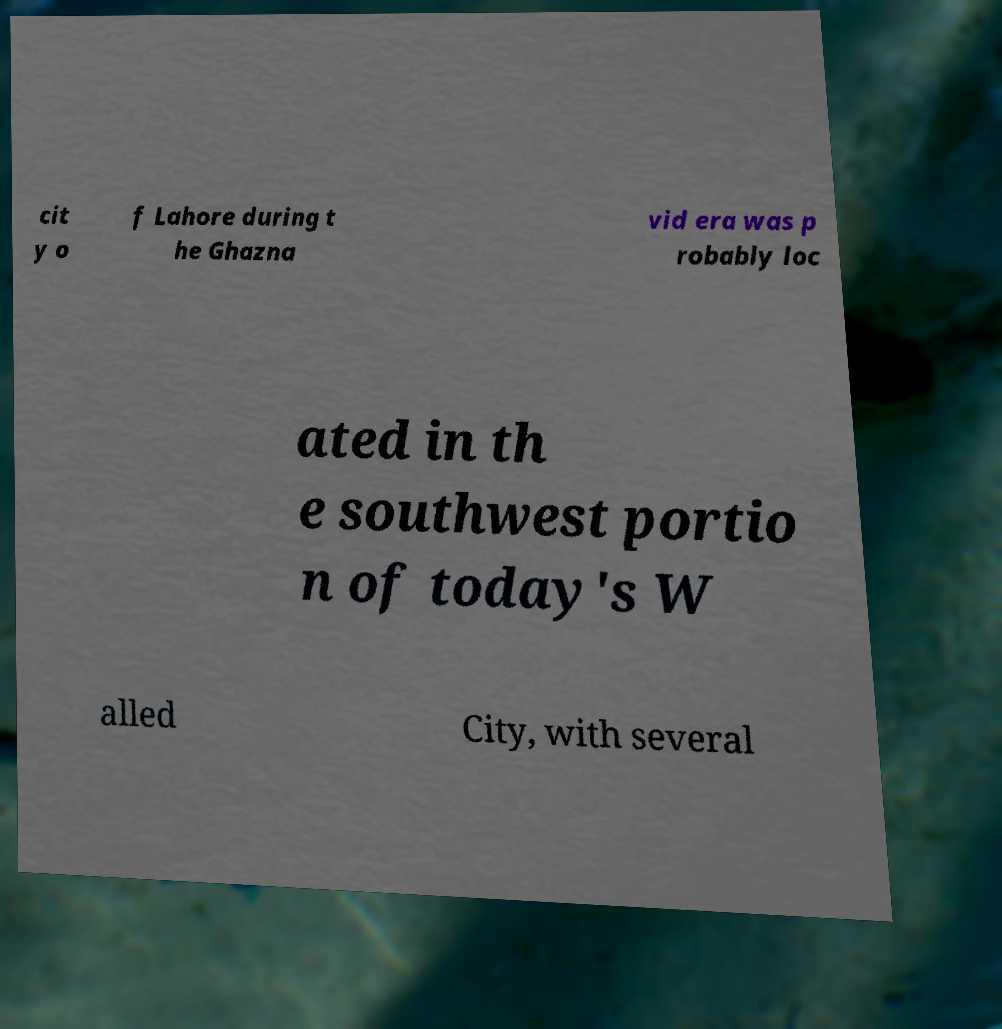Could you extract and type out the text from this image? cit y o f Lahore during t he Ghazna vid era was p robably loc ated in th e southwest portio n of today's W alled City, with several 